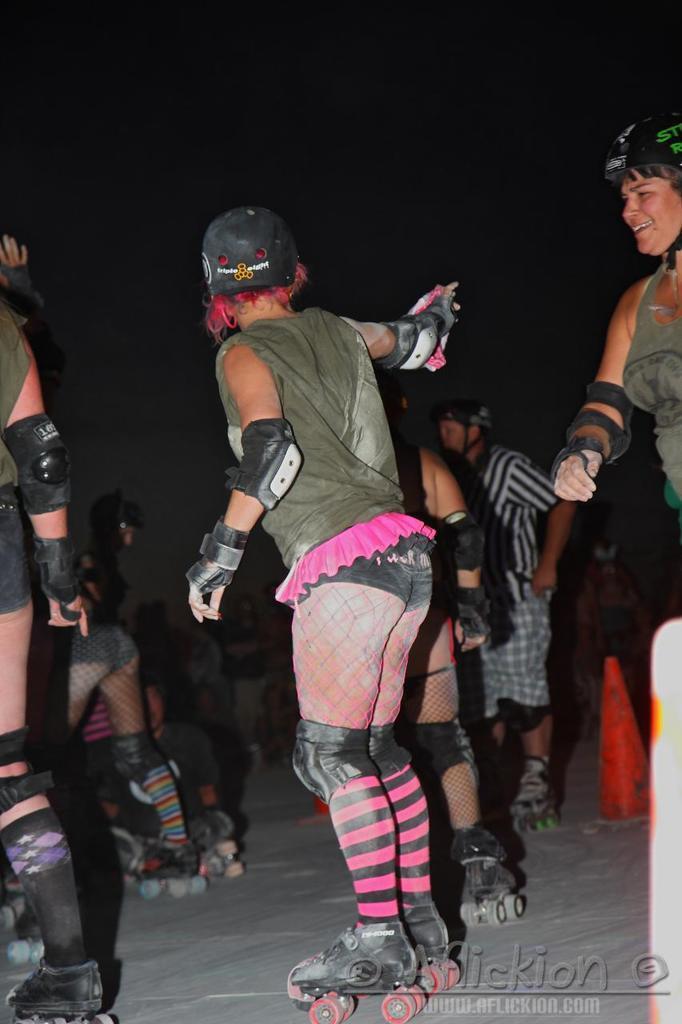Could you give a brief overview of what you see in this image? As we can see in the image there are group of people wearing helmets, green color dresses and skating. The image is little dark. 